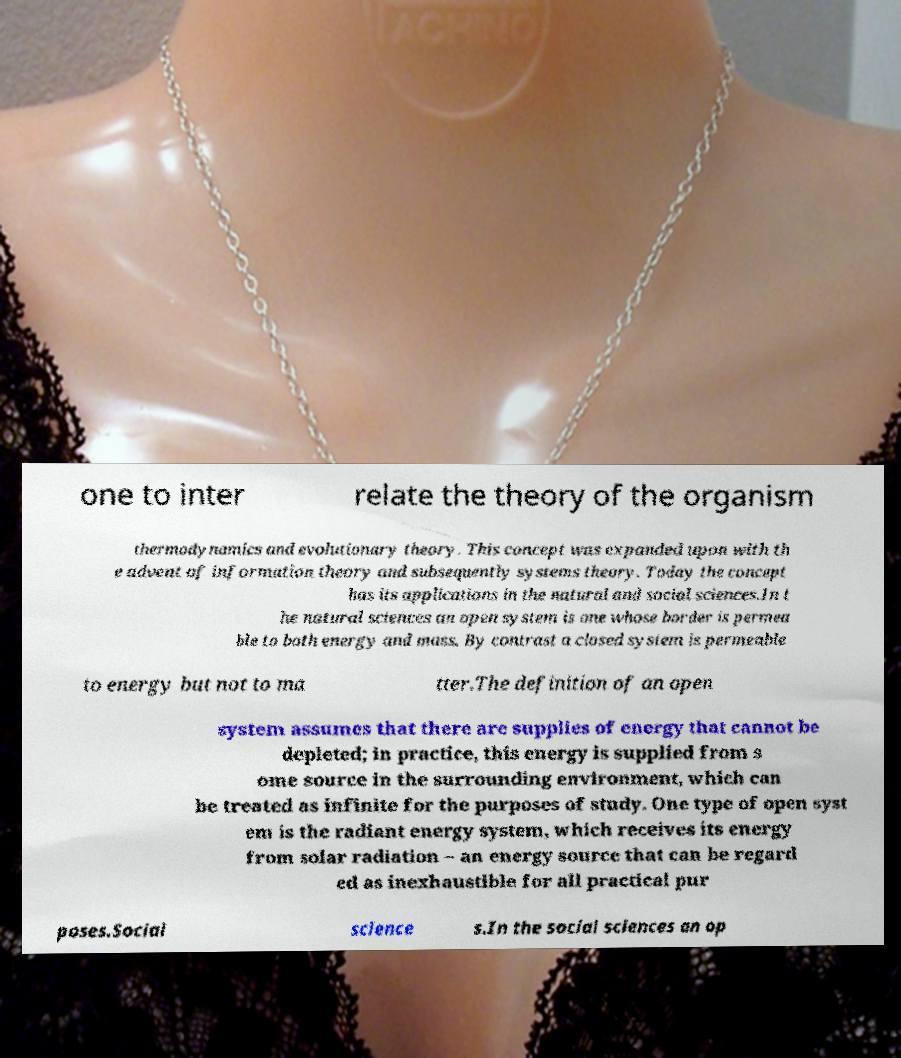Please read and relay the text visible in this image. What does it say? one to inter relate the theory of the organism thermodynamics and evolutionary theory. This concept was expanded upon with th e advent of information theory and subsequently systems theory. Today the concept has its applications in the natural and social sciences.In t he natural sciences an open system is one whose border is permea ble to both energy and mass. By contrast a closed system is permeable to energy but not to ma tter.The definition of an open system assumes that there are supplies of energy that cannot be depleted; in practice, this energy is supplied from s ome source in the surrounding environment, which can be treated as infinite for the purposes of study. One type of open syst em is the radiant energy system, which receives its energy from solar radiation – an energy source that can be regard ed as inexhaustible for all practical pur poses.Social science s.In the social sciences an op 